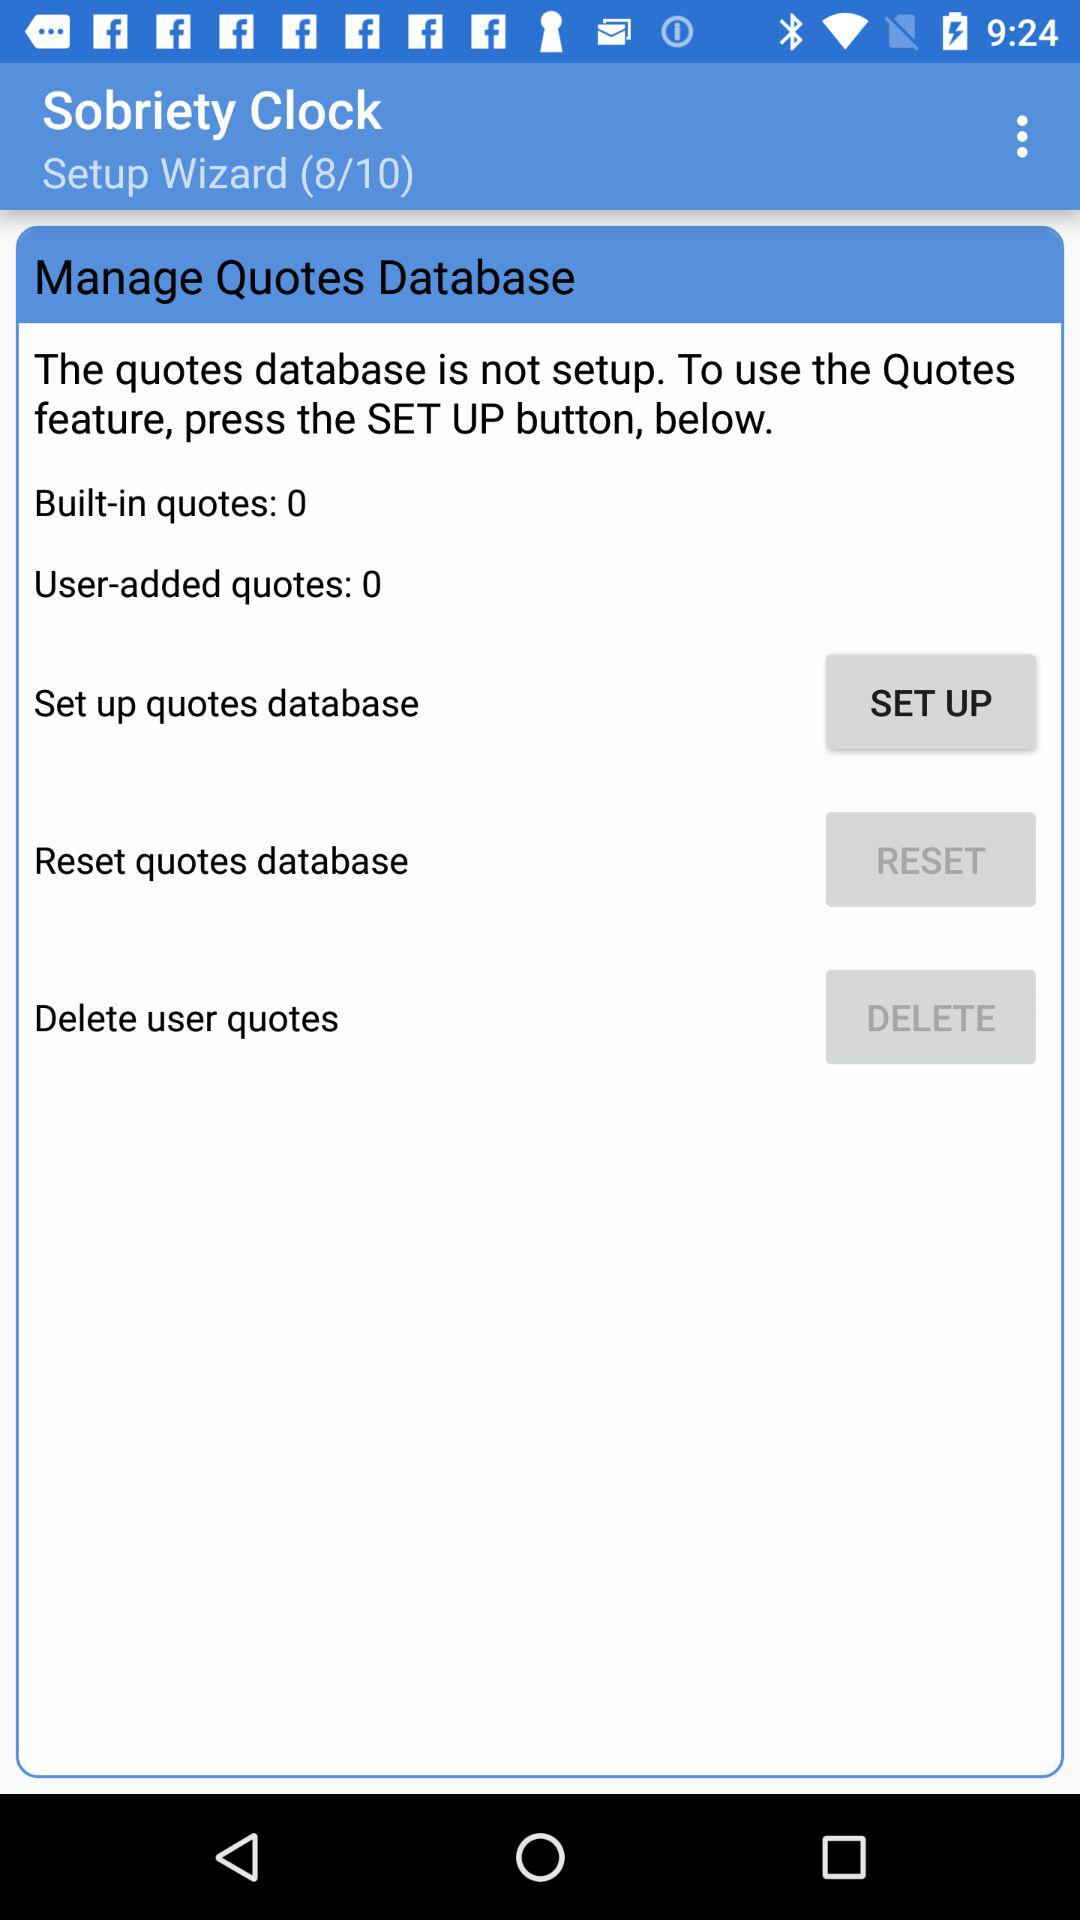What is the count of user-added quotes? The count of user-added quotes is 0. 